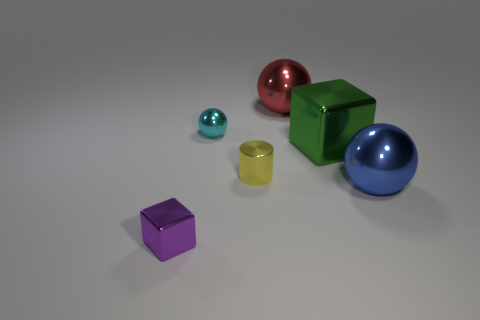Is the number of green objects that are on the left side of the yellow shiny cylinder greater than the number of small cubes that are in front of the purple cube?
Your response must be concise. No. Do the blue metallic thing that is in front of the red metallic object and the thing that is in front of the blue object have the same shape?
Ensure brevity in your answer.  No. How many other things are the same size as the red metal thing?
Offer a terse response. 2. The blue object is what size?
Make the answer very short. Large. Does the thing that is behind the tiny cyan sphere have the same material as the small sphere?
Ensure brevity in your answer.  Yes. The other metallic object that is the same shape as the green thing is what color?
Offer a very short reply. Purple. Does the large metal thing behind the cyan metal sphere have the same color as the tiny metallic ball?
Your response must be concise. No. There is a big blue shiny sphere; are there any tiny cyan objects right of it?
Give a very brief answer. No. There is a sphere that is on the left side of the green object and right of the small yellow object; what is its color?
Your answer should be very brief. Red. There is a thing in front of the metal ball that is in front of the tiny yellow shiny cylinder; how big is it?
Your answer should be very brief. Small. 